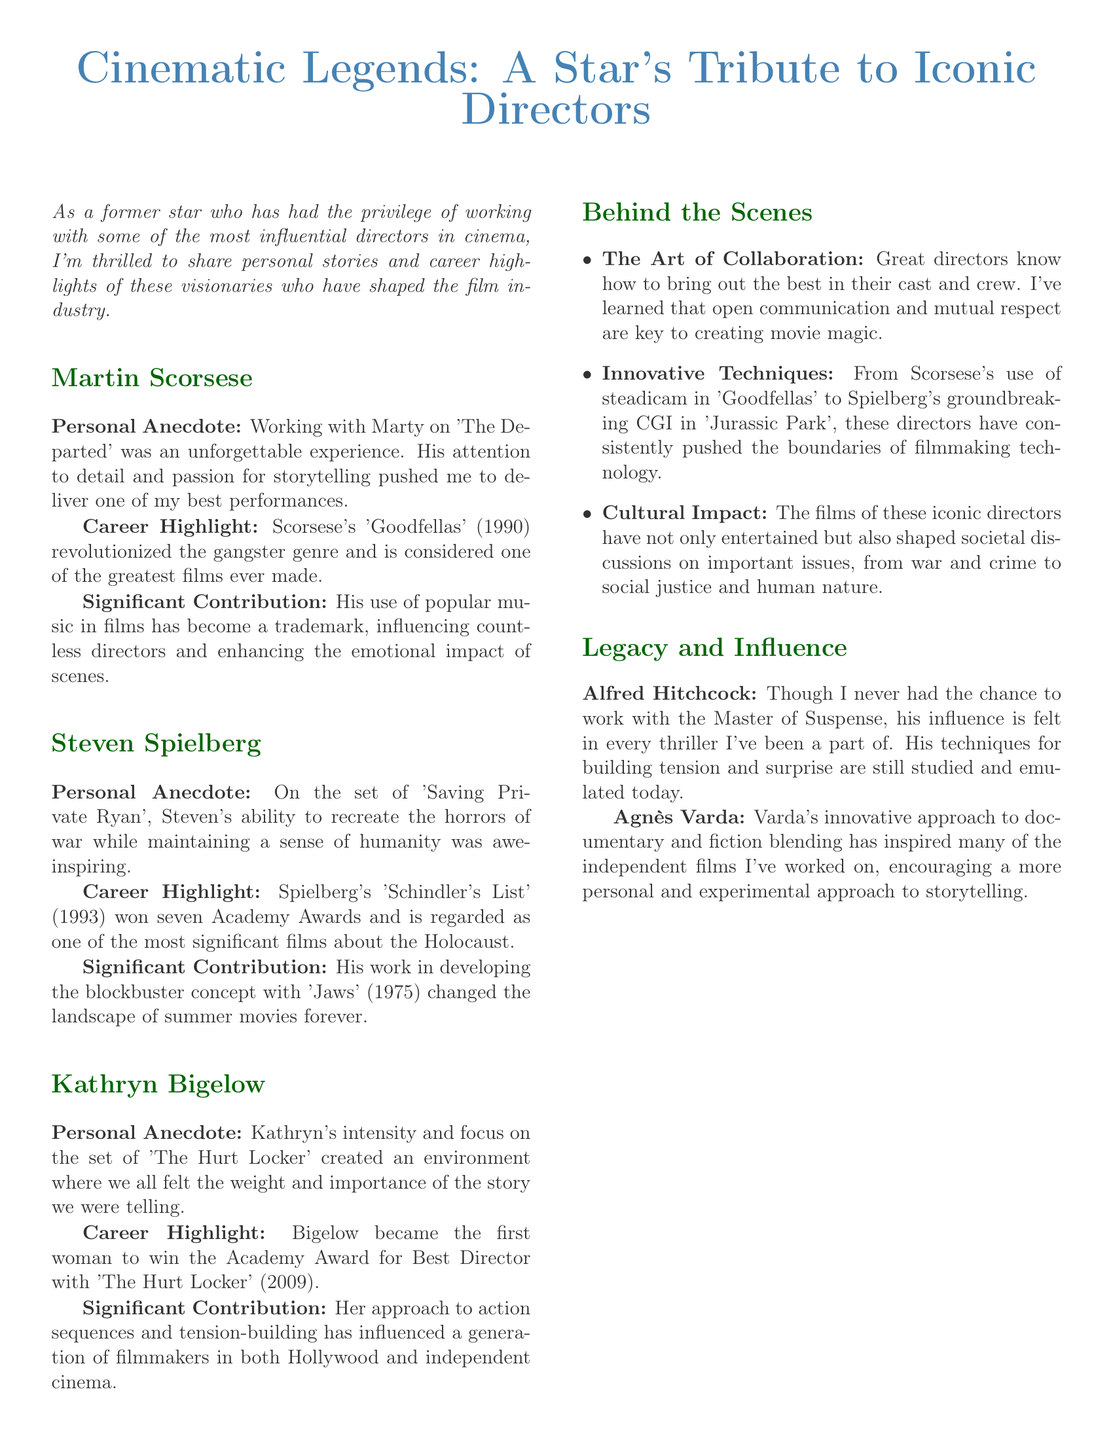What is the title of the newsletter? The title of the newsletter is prominently displayed at the top of the document.
Answer: Cinematic Legends: A Star's Tribute to Iconic Directors Who directed 'The Departed'? The personal anecdote mentions working with the director of 'The Departed'.
Answer: Martin Scorsese Which movie won Kathryn Bigelow the Academy Award for Best Director? The career highlight for Kathryn Bigelow states the film for which she won the award.
Answer: The Hurt Locker How many Academy Awards did 'Schindler's List' win? The career highlight for Spielberg mentions the number of Academy Awards won by the film.
Answer: Seven What innovative technique is associated with Scorsese? The section on Innovative Techniques specifically mentions a technique used in 'Goodfellas'.
Answer: Steadicam Which director's techniques for building tension are still studied today? The legacy section discusses the influence of this director in relation to tension-building.
Answer: Alfred Hitchcock What is emphasized as key to creating movie magic? The Behind the Scenes section describes important aspects of collaboration.
Answer: Open communication and mutual respect What is the significance of Agnès Varda in independent films? The legacy and influence section highlights her approach in the context of independent filmmaking.
Answer: Blending documentary and fiction What is the primary focus of the newsletter's conclusion? The conclusion elaborates on what is being celebrated through the discussion of directors.
Answer: The collaborative spirit of filmmaking 